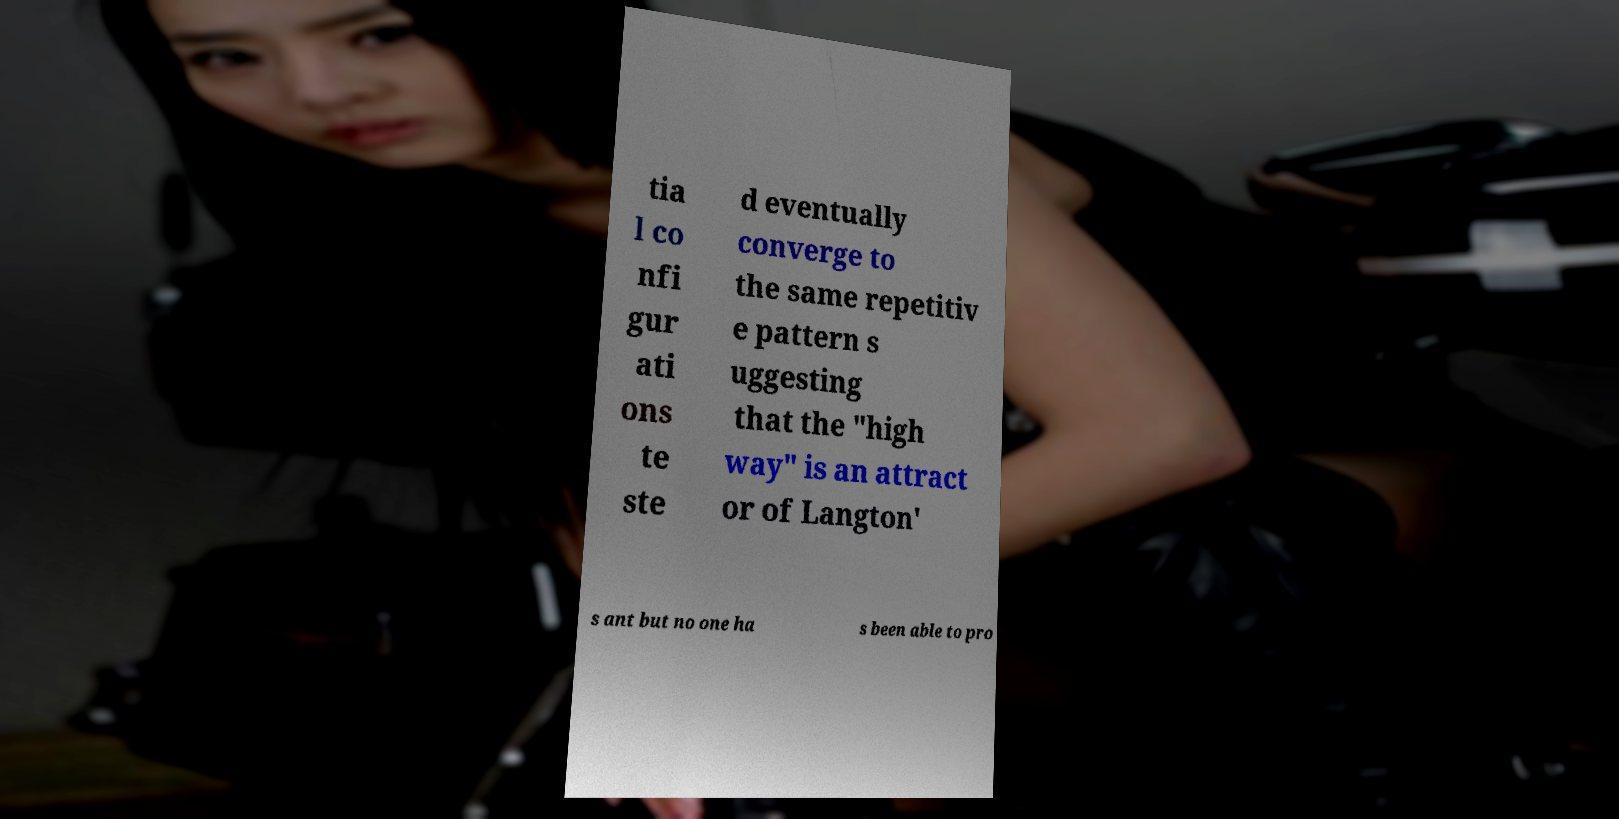For documentation purposes, I need the text within this image transcribed. Could you provide that? tia l co nfi gur ati ons te ste d eventually converge to the same repetitiv e pattern s uggesting that the "high way" is an attract or of Langton' s ant but no one ha s been able to pro 